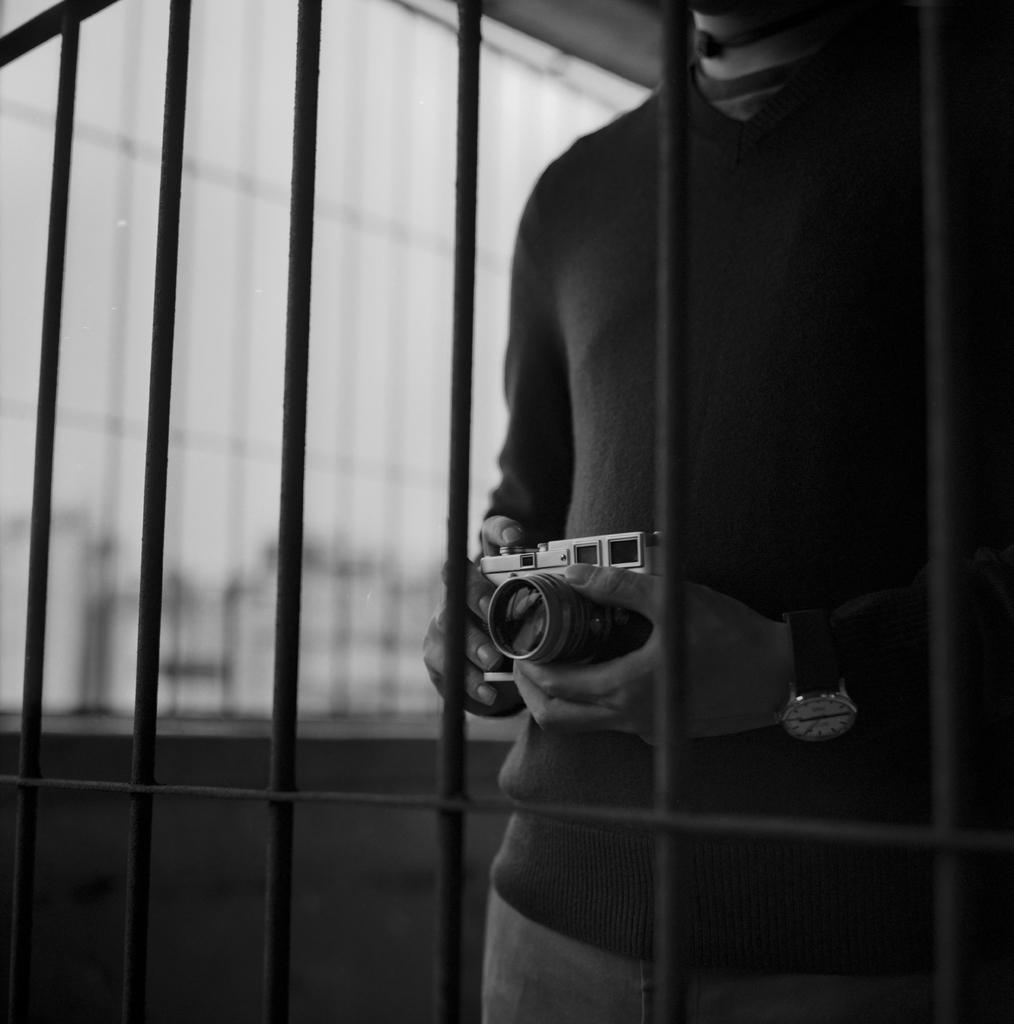Who is the main subject in the image? There is a man in the image. Where is the man positioned in the image? The man is standing in the center of the image. What is the man holding in his hand? The man is holding a camera in his hand. What can be seen in the front of the image? There are bars in the front of the image. What type of shoes is the man wearing in the image? There is no information about the man's shoes in the image, so we cannot determine what type of shoes he is wearing. 